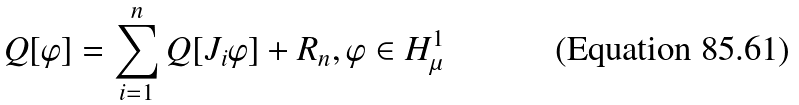Convert formula to latex. <formula><loc_0><loc_0><loc_500><loc_500>Q [ \varphi ] = \sum _ { i = 1 } ^ { n } Q [ J _ { i } \varphi ] + R _ { n } , \varphi \in H ^ { 1 } _ { \mu }</formula> 